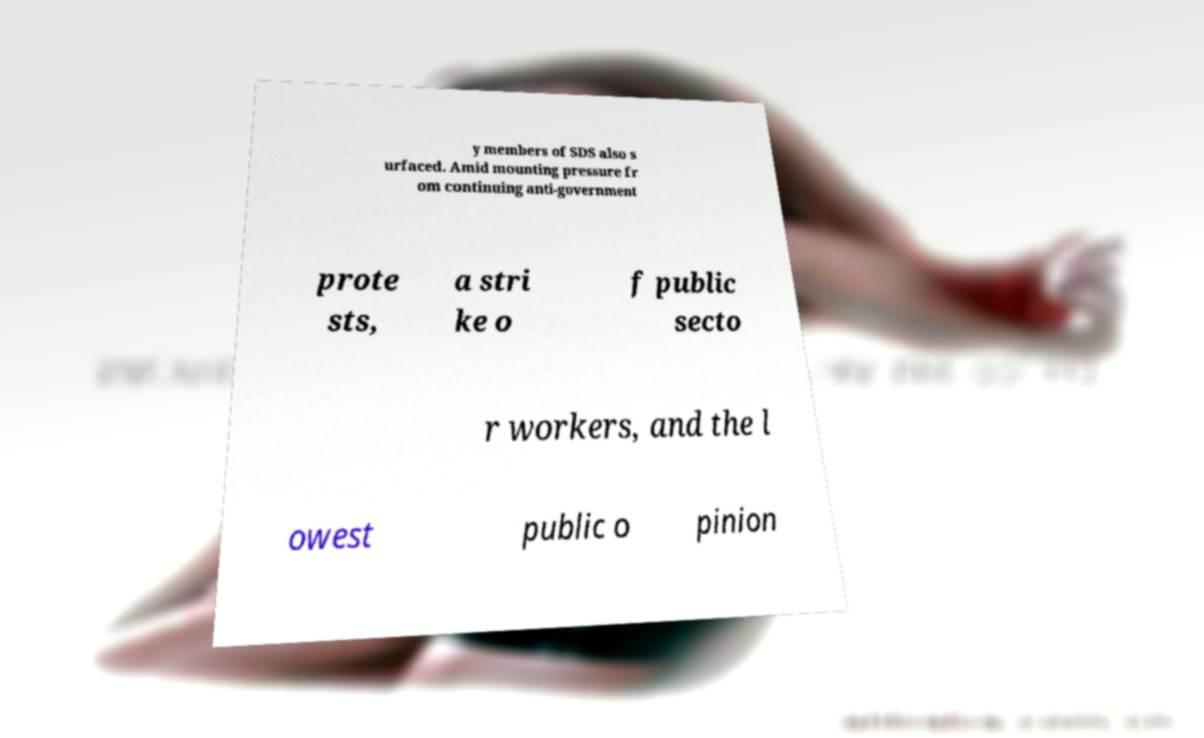Could you extract and type out the text from this image? y members of SDS also s urfaced. Amid mounting pressure fr om continuing anti-government prote sts, a stri ke o f public secto r workers, and the l owest public o pinion 